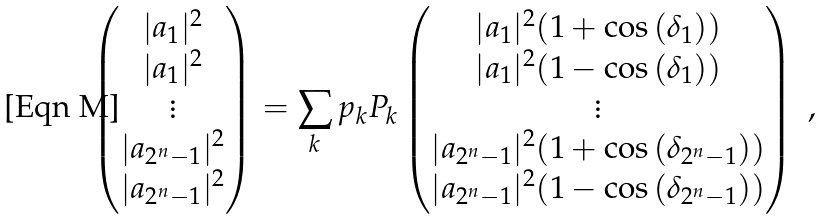Convert formula to latex. <formula><loc_0><loc_0><loc_500><loc_500>\begin{pmatrix} | a _ { 1 } | ^ { 2 } \\ | a _ { 1 } | ^ { 2 } \\ \vdots \\ | a _ { 2 ^ { n } - 1 } | ^ { 2 } \\ | a _ { 2 ^ { n } - 1 } | ^ { 2 } \\ \end{pmatrix} = \sum _ { k } p _ { k } P _ { k } \begin{pmatrix} | a _ { 1 } | ^ { 2 } ( 1 + \cos { ( \delta _ { 1 } ) } ) \\ | a _ { 1 } | ^ { 2 } ( 1 - \cos { ( \delta _ { 1 } ) } ) \\ \vdots \\ | a _ { 2 ^ { n } - 1 } | ^ { 2 } ( 1 + \cos { ( \delta _ { 2 ^ { n } - 1 } ) } ) \\ | a _ { 2 ^ { n } - 1 } | ^ { 2 } ( 1 - \cos { ( \delta _ { 2 ^ { n } - 1 } ) } ) \\ \end{pmatrix} \ ,</formula> 